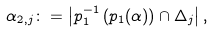Convert formula to latex. <formula><loc_0><loc_0><loc_500><loc_500>\alpha _ { 2 , j } \colon = \left | p _ { 1 } ^ { - 1 } \left ( p _ { 1 } ( \alpha ) \right ) \cap \Delta _ { j } \right | ,</formula> 